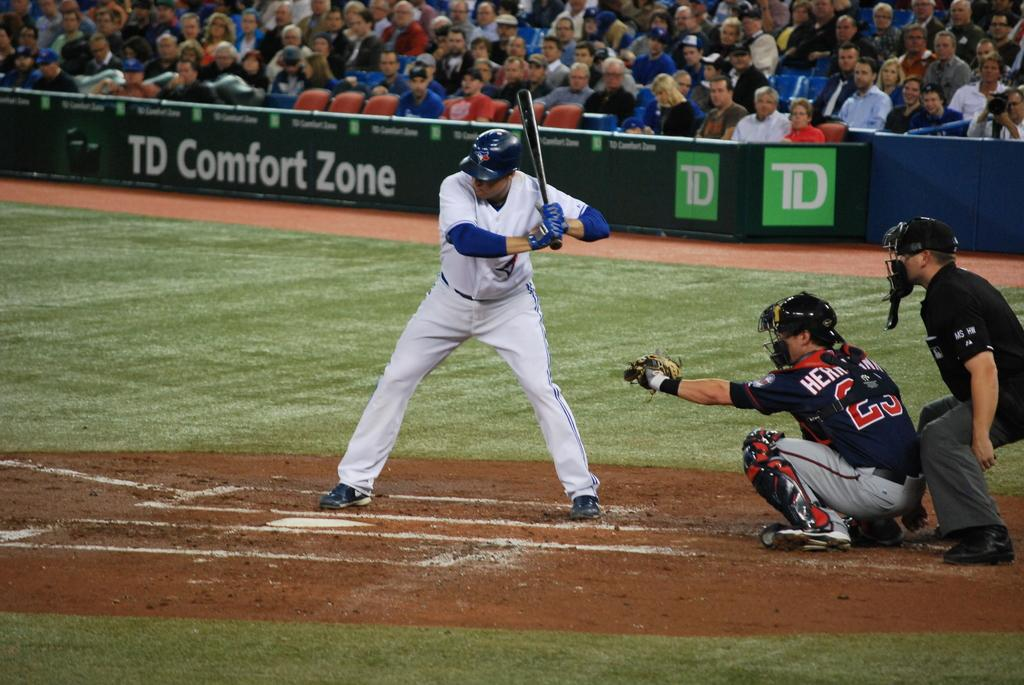<image>
Offer a succinct explanation of the picture presented. The banner displayed behind the baseball player advertises TD Comfort Zone. 